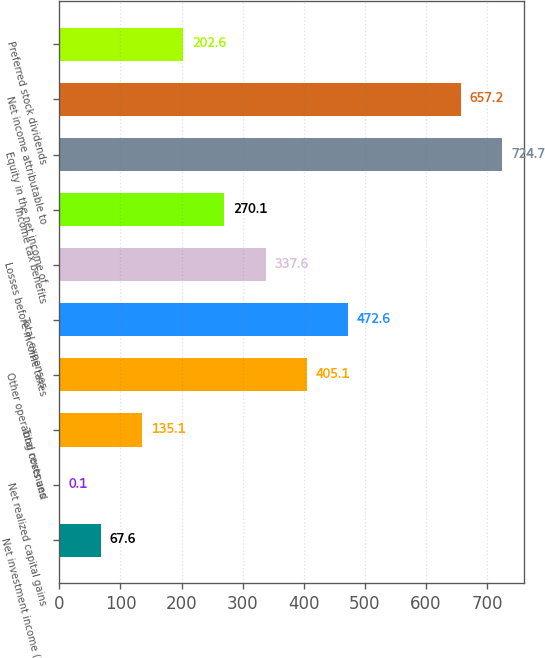<chart> <loc_0><loc_0><loc_500><loc_500><bar_chart><fcel>Net investment income (loss)<fcel>Net realized capital gains<fcel>Total revenues<fcel>Other operating costs and<fcel>Total expenses<fcel>Losses before income taxes<fcel>Income tax benefits<fcel>Equity in the net income of<fcel>Net income attributable to<fcel>Preferred stock dividends<nl><fcel>67.6<fcel>0.1<fcel>135.1<fcel>405.1<fcel>472.6<fcel>337.6<fcel>270.1<fcel>724.7<fcel>657.2<fcel>202.6<nl></chart> 